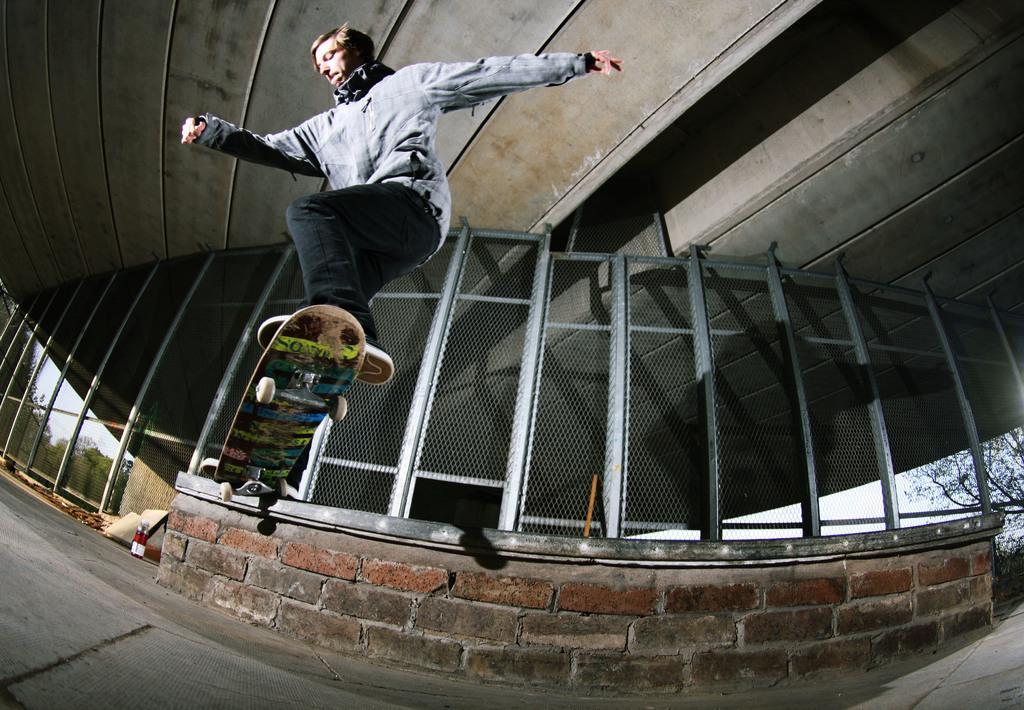In one or two sentences, can you explain what this image depicts? In this image a person is jumping in the air along with the skateboard. Bottom of the image there is a floor having a wall which is having a fence on it. Left side there is a bottle and few objects are on the floor. Behind the fence there are few trees. Right bottom there are few trees and plants. 